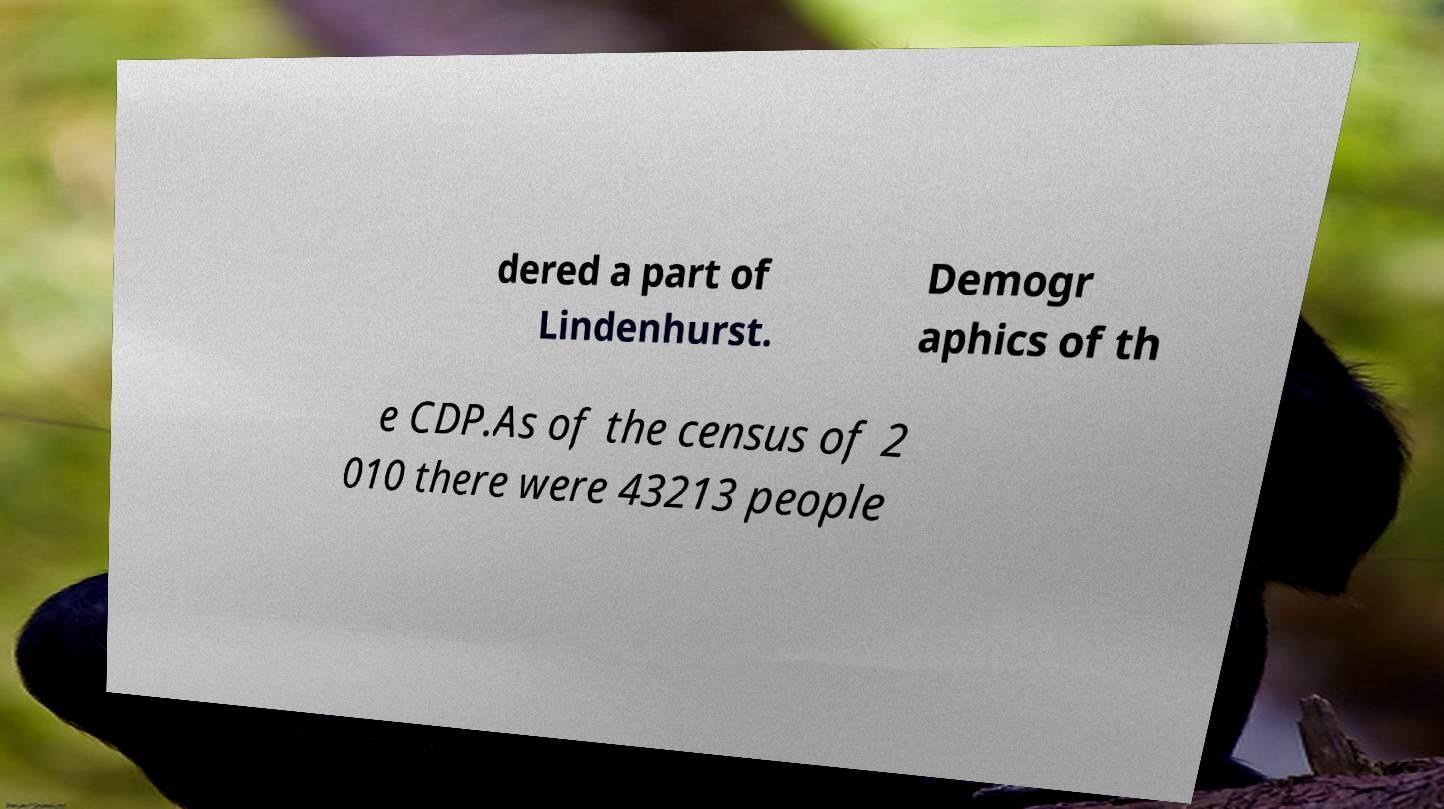Please identify and transcribe the text found in this image. dered a part of Lindenhurst. Demogr aphics of th e CDP.As of the census of 2 010 there were 43213 people 